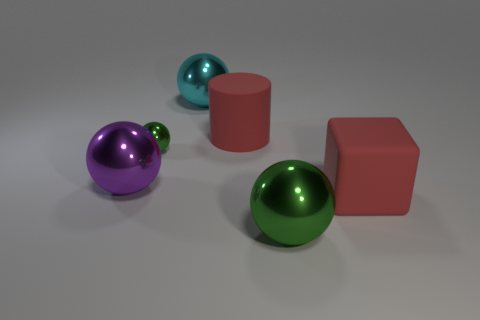What materials do the objects in the image appear to be made of? The objects in the image seem to have smooth, reflective surfaces, akin to materials such as metal or polished plastic. They reflect light and surroundings, suggesting a shiny, possibly metallic texture. The visual cues indicate that they are solid and have a weighty presence, which is often associated with metals or dense plastics. 